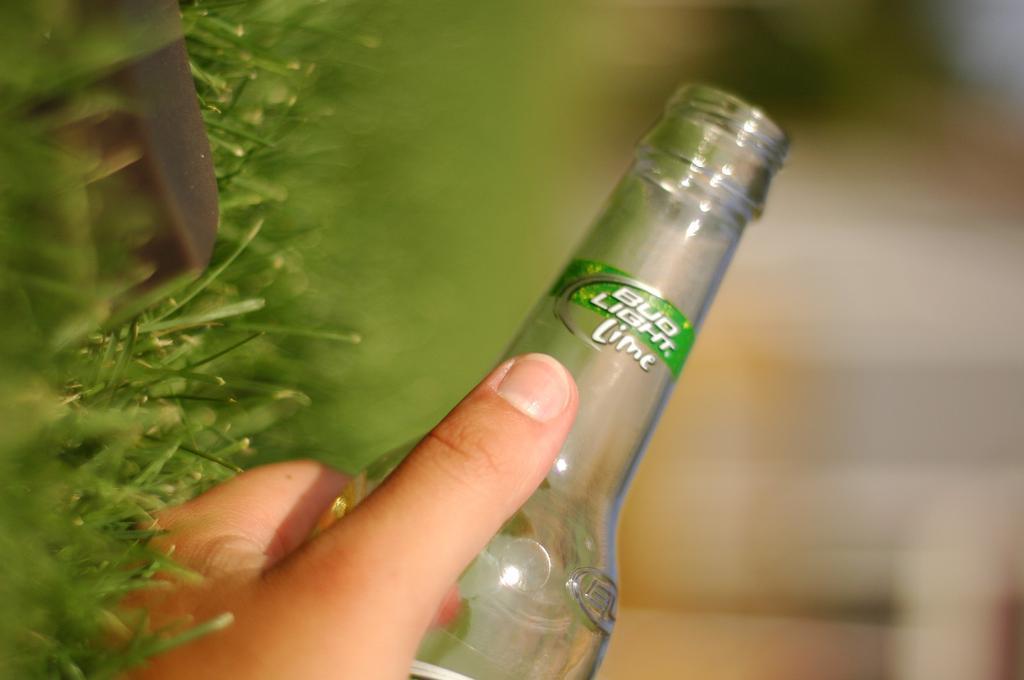Can you describe this image briefly? In the middle of the image a person is holding a bottle. Bottom left side of the image there is a grass. 